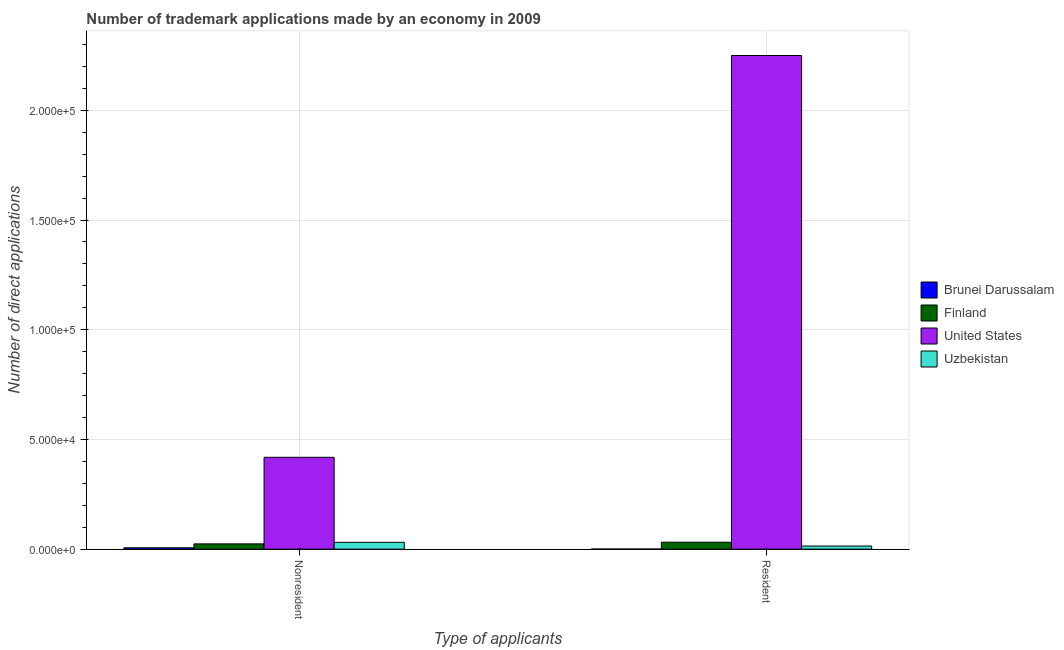How many groups of bars are there?
Offer a very short reply. 2. Are the number of bars per tick equal to the number of legend labels?
Your answer should be very brief. Yes. Are the number of bars on each tick of the X-axis equal?
Offer a terse response. Yes. How many bars are there on the 2nd tick from the left?
Provide a short and direct response. 4. What is the label of the 2nd group of bars from the left?
Make the answer very short. Resident. What is the number of trademark applications made by residents in Brunei Darussalam?
Give a very brief answer. 35. Across all countries, what is the maximum number of trademark applications made by residents?
Provide a succinct answer. 2.25e+05. Across all countries, what is the minimum number of trademark applications made by residents?
Make the answer very short. 35. In which country was the number of trademark applications made by non residents maximum?
Make the answer very short. United States. In which country was the number of trademark applications made by non residents minimum?
Ensure brevity in your answer.  Brunei Darussalam. What is the total number of trademark applications made by non residents in the graph?
Ensure brevity in your answer.  4.80e+04. What is the difference between the number of trademark applications made by residents in Uzbekistan and that in Brunei Darussalam?
Your answer should be very brief. 1396. What is the difference between the number of trademark applications made by non residents in Uzbekistan and the number of trademark applications made by residents in United States?
Keep it short and to the point. -2.22e+05. What is the average number of trademark applications made by non residents per country?
Provide a short and direct response. 1.20e+04. What is the difference between the number of trademark applications made by non residents and number of trademark applications made by residents in Brunei Darussalam?
Provide a succinct answer. 579. In how many countries, is the number of trademark applications made by non residents greater than 130000 ?
Your answer should be very brief. 0. What is the ratio of the number of trademark applications made by non residents in United States to that in Finland?
Offer a terse response. 17.45. What does the 1st bar from the left in Nonresident represents?
Give a very brief answer. Brunei Darussalam. What does the 1st bar from the right in Resident represents?
Offer a terse response. Uzbekistan. Are all the bars in the graph horizontal?
Your answer should be compact. No. How many countries are there in the graph?
Provide a short and direct response. 4. What is the difference between two consecutive major ticks on the Y-axis?
Offer a terse response. 5.00e+04. Are the values on the major ticks of Y-axis written in scientific E-notation?
Your response must be concise. Yes. Does the graph contain grids?
Give a very brief answer. Yes. How are the legend labels stacked?
Ensure brevity in your answer.  Vertical. What is the title of the graph?
Provide a short and direct response. Number of trademark applications made by an economy in 2009. Does "Oman" appear as one of the legend labels in the graph?
Your response must be concise. No. What is the label or title of the X-axis?
Offer a very short reply. Type of applicants. What is the label or title of the Y-axis?
Offer a terse response. Number of direct applications. What is the Number of direct applications in Brunei Darussalam in Nonresident?
Make the answer very short. 614. What is the Number of direct applications in Finland in Nonresident?
Provide a short and direct response. 2399. What is the Number of direct applications in United States in Nonresident?
Keep it short and to the point. 4.19e+04. What is the Number of direct applications of Uzbekistan in Nonresident?
Keep it short and to the point. 3110. What is the Number of direct applications of Brunei Darussalam in Resident?
Offer a very short reply. 35. What is the Number of direct applications in Finland in Resident?
Your response must be concise. 3165. What is the Number of direct applications of United States in Resident?
Keep it short and to the point. 2.25e+05. What is the Number of direct applications of Uzbekistan in Resident?
Ensure brevity in your answer.  1431. Across all Type of applicants, what is the maximum Number of direct applications in Brunei Darussalam?
Offer a terse response. 614. Across all Type of applicants, what is the maximum Number of direct applications in Finland?
Provide a short and direct response. 3165. Across all Type of applicants, what is the maximum Number of direct applications in United States?
Your answer should be compact. 2.25e+05. Across all Type of applicants, what is the maximum Number of direct applications of Uzbekistan?
Provide a short and direct response. 3110. Across all Type of applicants, what is the minimum Number of direct applications of Brunei Darussalam?
Provide a short and direct response. 35. Across all Type of applicants, what is the minimum Number of direct applications of Finland?
Give a very brief answer. 2399. Across all Type of applicants, what is the minimum Number of direct applications in United States?
Keep it short and to the point. 4.19e+04. Across all Type of applicants, what is the minimum Number of direct applications of Uzbekistan?
Offer a very short reply. 1431. What is the total Number of direct applications of Brunei Darussalam in the graph?
Give a very brief answer. 649. What is the total Number of direct applications in Finland in the graph?
Give a very brief answer. 5564. What is the total Number of direct applications in United States in the graph?
Provide a succinct answer. 2.67e+05. What is the total Number of direct applications in Uzbekistan in the graph?
Provide a short and direct response. 4541. What is the difference between the Number of direct applications in Brunei Darussalam in Nonresident and that in Resident?
Your answer should be very brief. 579. What is the difference between the Number of direct applications of Finland in Nonresident and that in Resident?
Your answer should be compact. -766. What is the difference between the Number of direct applications of United States in Nonresident and that in Resident?
Ensure brevity in your answer.  -1.83e+05. What is the difference between the Number of direct applications of Uzbekistan in Nonresident and that in Resident?
Your answer should be compact. 1679. What is the difference between the Number of direct applications of Brunei Darussalam in Nonresident and the Number of direct applications of Finland in Resident?
Your answer should be very brief. -2551. What is the difference between the Number of direct applications in Brunei Darussalam in Nonresident and the Number of direct applications in United States in Resident?
Provide a short and direct response. -2.24e+05. What is the difference between the Number of direct applications in Brunei Darussalam in Nonresident and the Number of direct applications in Uzbekistan in Resident?
Offer a terse response. -817. What is the difference between the Number of direct applications in Finland in Nonresident and the Number of direct applications in United States in Resident?
Your answer should be compact. -2.23e+05. What is the difference between the Number of direct applications in Finland in Nonresident and the Number of direct applications in Uzbekistan in Resident?
Give a very brief answer. 968. What is the difference between the Number of direct applications of United States in Nonresident and the Number of direct applications of Uzbekistan in Resident?
Your answer should be very brief. 4.04e+04. What is the average Number of direct applications of Brunei Darussalam per Type of applicants?
Make the answer very short. 324.5. What is the average Number of direct applications of Finland per Type of applicants?
Your answer should be compact. 2782. What is the average Number of direct applications in United States per Type of applicants?
Offer a very short reply. 1.33e+05. What is the average Number of direct applications of Uzbekistan per Type of applicants?
Your answer should be very brief. 2270.5. What is the difference between the Number of direct applications of Brunei Darussalam and Number of direct applications of Finland in Nonresident?
Keep it short and to the point. -1785. What is the difference between the Number of direct applications of Brunei Darussalam and Number of direct applications of United States in Nonresident?
Keep it short and to the point. -4.12e+04. What is the difference between the Number of direct applications of Brunei Darussalam and Number of direct applications of Uzbekistan in Nonresident?
Your response must be concise. -2496. What is the difference between the Number of direct applications of Finland and Number of direct applications of United States in Nonresident?
Your response must be concise. -3.95e+04. What is the difference between the Number of direct applications of Finland and Number of direct applications of Uzbekistan in Nonresident?
Keep it short and to the point. -711. What is the difference between the Number of direct applications of United States and Number of direct applications of Uzbekistan in Nonresident?
Give a very brief answer. 3.88e+04. What is the difference between the Number of direct applications of Brunei Darussalam and Number of direct applications of Finland in Resident?
Your response must be concise. -3130. What is the difference between the Number of direct applications in Brunei Darussalam and Number of direct applications in United States in Resident?
Your answer should be very brief. -2.25e+05. What is the difference between the Number of direct applications in Brunei Darussalam and Number of direct applications in Uzbekistan in Resident?
Offer a terse response. -1396. What is the difference between the Number of direct applications in Finland and Number of direct applications in United States in Resident?
Offer a terse response. -2.22e+05. What is the difference between the Number of direct applications of Finland and Number of direct applications of Uzbekistan in Resident?
Offer a very short reply. 1734. What is the difference between the Number of direct applications in United States and Number of direct applications in Uzbekistan in Resident?
Your answer should be compact. 2.24e+05. What is the ratio of the Number of direct applications in Brunei Darussalam in Nonresident to that in Resident?
Make the answer very short. 17.54. What is the ratio of the Number of direct applications in Finland in Nonresident to that in Resident?
Provide a short and direct response. 0.76. What is the ratio of the Number of direct applications in United States in Nonresident to that in Resident?
Offer a terse response. 0.19. What is the ratio of the Number of direct applications of Uzbekistan in Nonresident to that in Resident?
Your answer should be compact. 2.17. What is the difference between the highest and the second highest Number of direct applications of Brunei Darussalam?
Keep it short and to the point. 579. What is the difference between the highest and the second highest Number of direct applications of Finland?
Your answer should be compact. 766. What is the difference between the highest and the second highest Number of direct applications in United States?
Keep it short and to the point. 1.83e+05. What is the difference between the highest and the second highest Number of direct applications in Uzbekistan?
Your response must be concise. 1679. What is the difference between the highest and the lowest Number of direct applications of Brunei Darussalam?
Your answer should be compact. 579. What is the difference between the highest and the lowest Number of direct applications of Finland?
Provide a succinct answer. 766. What is the difference between the highest and the lowest Number of direct applications in United States?
Keep it short and to the point. 1.83e+05. What is the difference between the highest and the lowest Number of direct applications in Uzbekistan?
Offer a very short reply. 1679. 